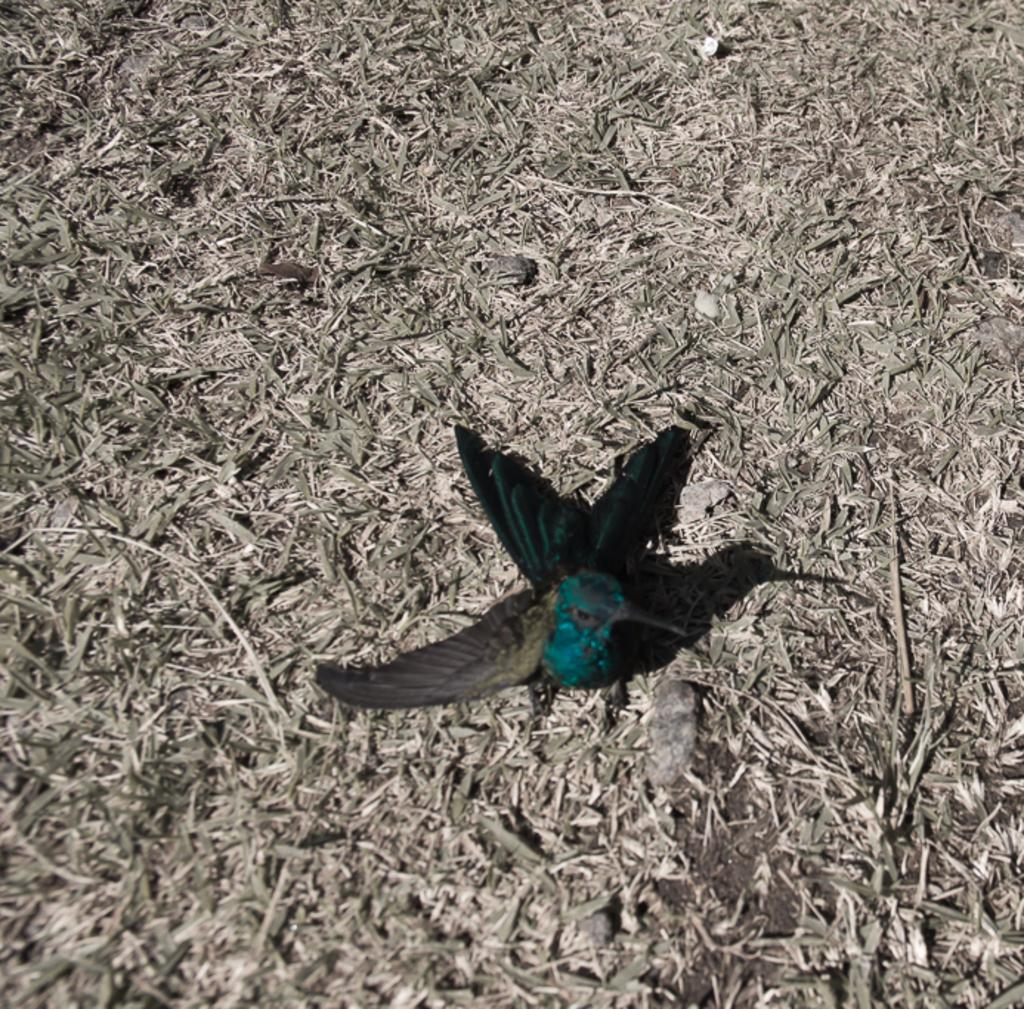What type of vegetation is present in the image? There is grass in the image. What type of animal can be seen in the image? There is a bird in the image. Where is the bird located in the image? The bird is in the center of the image. What colors are the bird's feathers? The bird is black and green in color. How many tomatoes are on the bird's beak in the image? There are no tomatoes present in the image, and the bird's beak is not visible. What is the level of noise in the office depicted in the image? There is no office present in the image, so it is not possible to determine the noise level. 